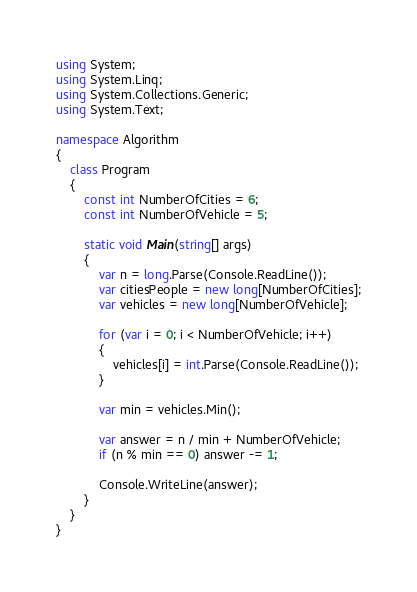<code> <loc_0><loc_0><loc_500><loc_500><_C#_>using System;
using System.Linq;
using System.Collections.Generic;
using System.Text;

namespace Algorithm
{
    class Program
    {
        const int NumberOfCities = 6;
        const int NumberOfVehicle = 5;

        static void Main(string[] args)
        {
            var n = long.Parse(Console.ReadLine());
            var citiesPeople = new long[NumberOfCities];
            var vehicles = new long[NumberOfVehicle];

            for (var i = 0; i < NumberOfVehicle; i++)
            {
                vehicles[i] = int.Parse(Console.ReadLine());
            }

            var min = vehicles.Min();

            var answer = n / min + NumberOfVehicle;
            if (n % min == 0) answer -= 1;

            Console.WriteLine(answer);
        }
    }
}
</code> 